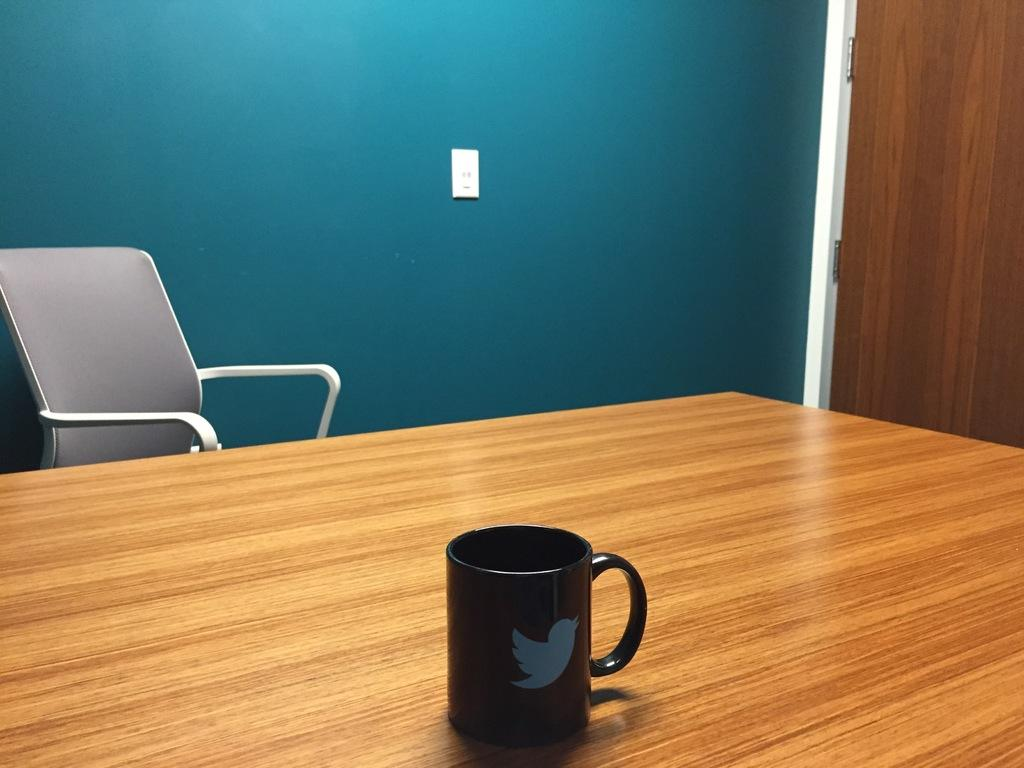What type of furniture is present in the image? There is a chair in the image. What is on the table in the image? There is a cup on a table in the image. Can you identify any architectural features in the image? Yes, there is a door in the image. Where is the brush located in the image? There is no brush present in the image. How many steps can be seen in the image? There are no steps visible in the image. 